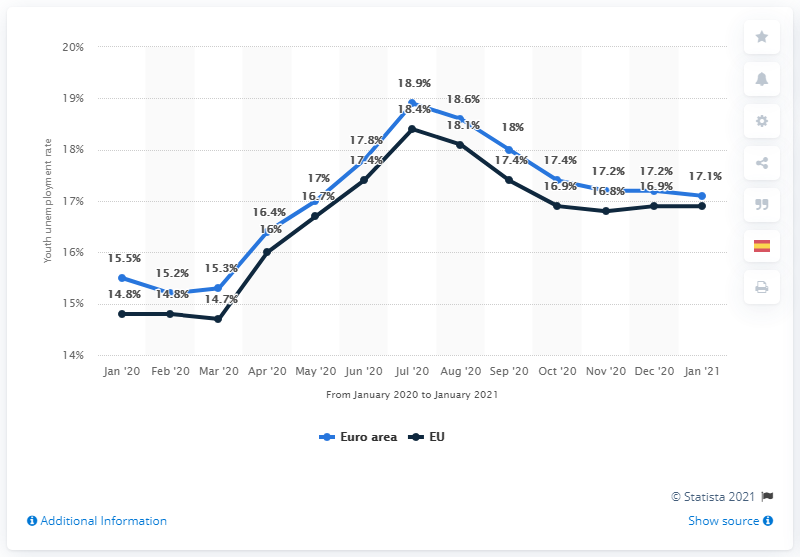Give some essential details in this illustration. The highest value in the blue line is 18.9. The blue line moved 1.6 percentage points from January 20 to January 21. 